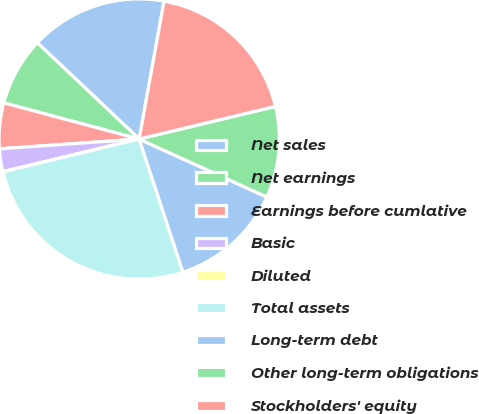Convert chart. <chart><loc_0><loc_0><loc_500><loc_500><pie_chart><fcel>Net sales<fcel>Net earnings<fcel>Earnings before cumlative<fcel>Basic<fcel>Diluted<fcel>Total assets<fcel>Long-term debt<fcel>Other long-term obligations<fcel>Stockholders' equity<nl><fcel>15.79%<fcel>7.9%<fcel>5.27%<fcel>2.64%<fcel>0.01%<fcel>26.3%<fcel>13.16%<fcel>10.53%<fcel>18.42%<nl></chart> 